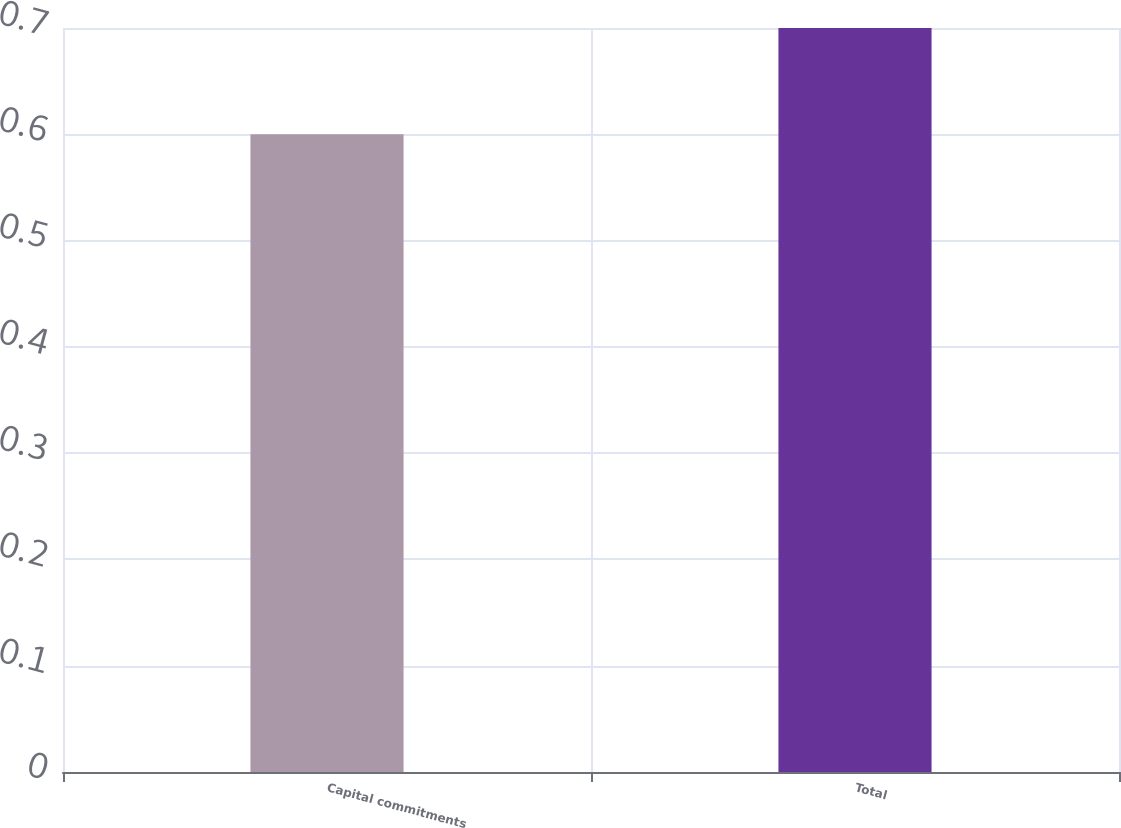Convert chart to OTSL. <chart><loc_0><loc_0><loc_500><loc_500><bar_chart><fcel>Capital commitments<fcel>Total<nl><fcel>0.6<fcel>0.7<nl></chart> 